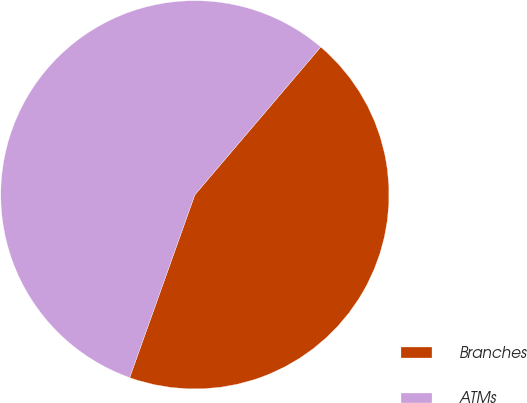Convert chart. <chart><loc_0><loc_0><loc_500><loc_500><pie_chart><fcel>Branches<fcel>ATMs<nl><fcel>44.22%<fcel>55.78%<nl></chart> 